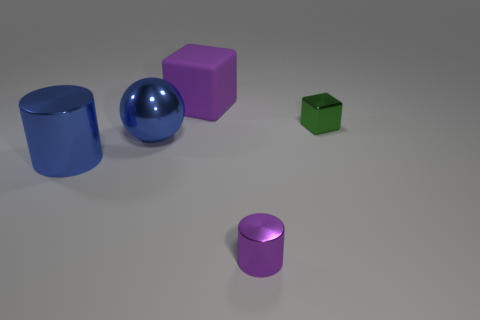Can you tell me which objects are closest to each other in the image? Certainly! The purple cube and the smaller purple cylinder are closest to each other when compared to their proximity to any other object in the image. 